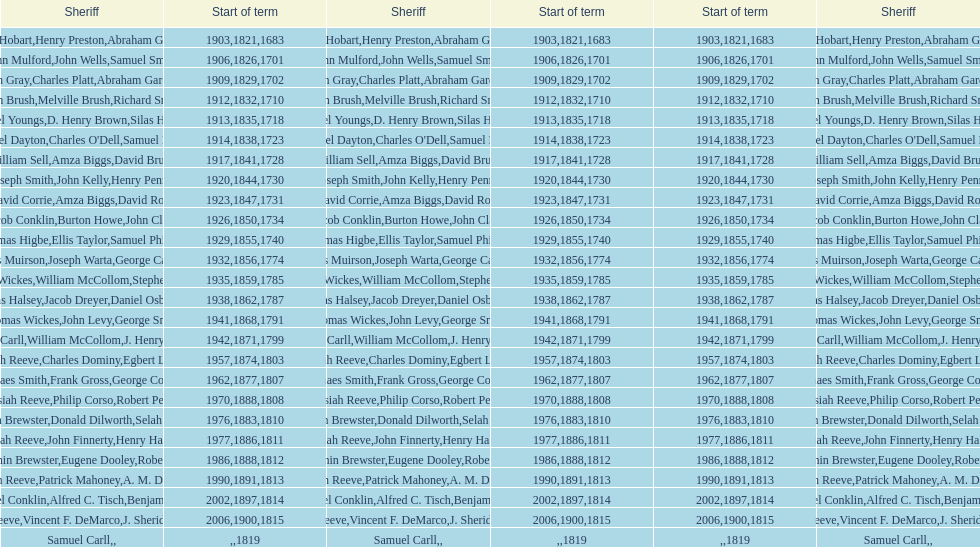What is the total number of sheriffs that were in office in suffolk county between 1903 and 1957? 17. 